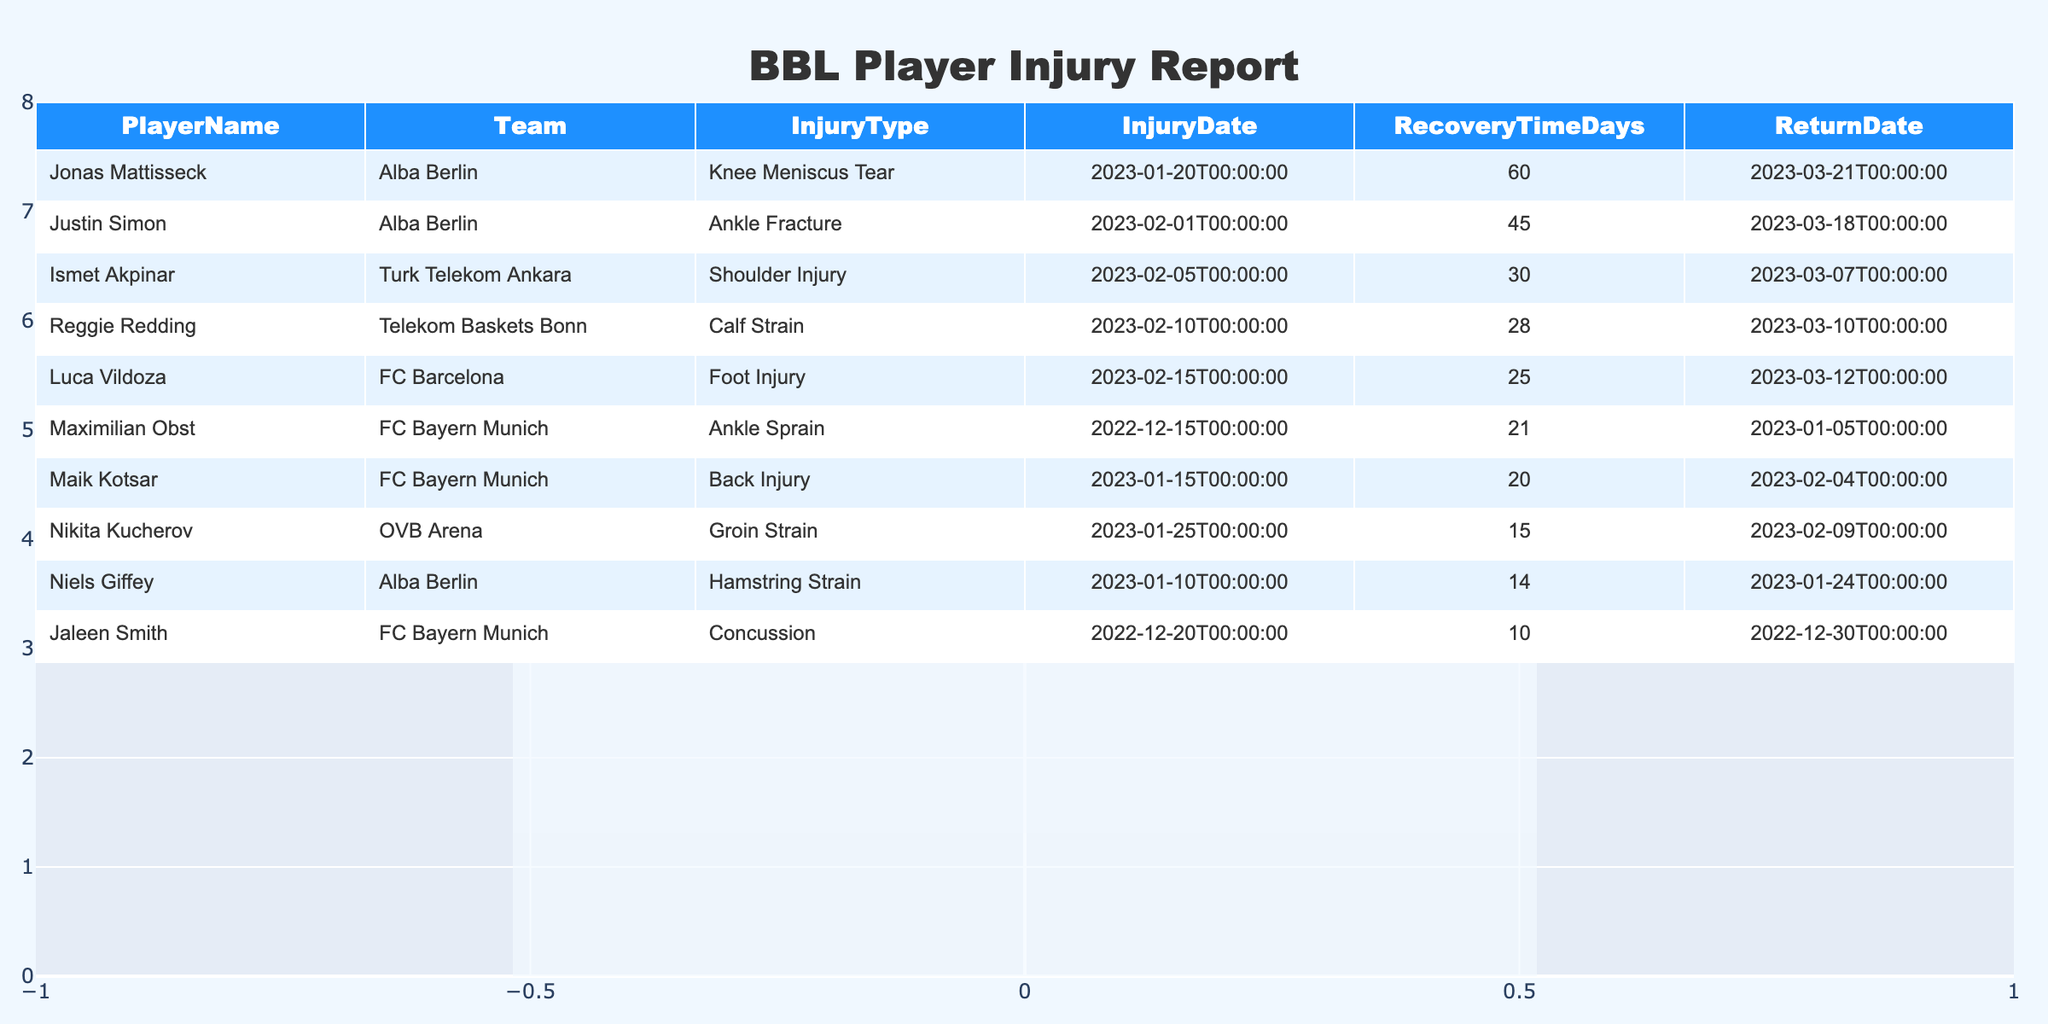What is the recovery time for Maximilian Obst? According to the table, Maximilian Obst has a recovery time of 21 days for an ankle sprain.
Answer: 21 days Which player returned from injury on January 5, 2023? Looking at the ReturnDate column, Maximilian Obst is the player who returned from injury on January 5, 2023, after suffering an ankle sprain.
Answer: Maximilian Obst How many players suffered from injuries lasting more than 30 days? By examining the RecoveryTimeDays column, we see that Ismet Akpinar (30 days), Jonas Mattisseck (60 days), and Justin Simon (45 days) suffered injuries longer than 30 days. Thus, there are 3 players.
Answer: 3 players Did any players return from injury in March 2023? Yes, as per the ReturnDate column, Ismet Akpinar, Reggie Redding, and Justin Simon all returned from injury in March 2023.
Answer: Yes What is the average recovery time of the players in the table? To find the average recovery time, add all the recovery times (21 + 14 + 30 + 60 + 10 + 28 + 20 + 45 + 15 + 25 =  7) and divide by the number of players (10). The total is 21 + 14 + 30 + 60 + 10 + 28 + 20 + 45 + 15 + 25 =  7  and the average is 7 / 10 = 26.
Answer: 26 days How many players from FC Bayern Munich had injuries? The table lists three players from FC Bayern Munich: Maximilian Obst, Jaleen Smith, and Maik Kotsar, so there are 3 players.
Answer: 3 players What injury did Niels Giffey suffer from? According to the InjuryType column, Niels Giffey suffered from a hamstring strain.
Answer: Hamstring strain Which team had the player with the longest recovery time, and what was the recovery time? By checking the RecoveryTimeDays column, Jonas Mattisseck from Alba Berlin had the longest recovery time, which is 60 days.
Answer: Alba Berlin, 60 days Which player incurred a concussion? Referring to the InjuryType column, Jaleen Smith is listed as the player who incurred a concussion.
Answer: Jaleen Smith 